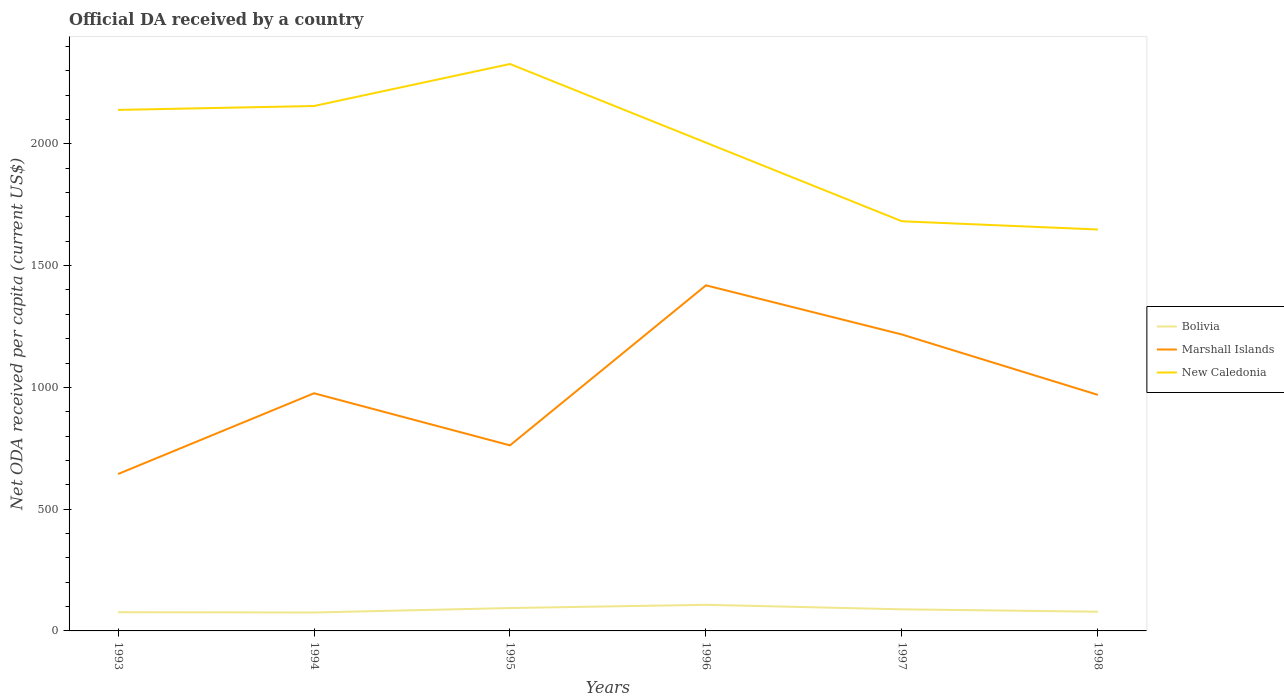How many different coloured lines are there?
Keep it short and to the point. 3. Is the number of lines equal to the number of legend labels?
Your answer should be very brief. Yes. Across all years, what is the maximum ODA received in in Bolivia?
Your answer should be compact. 75.66. What is the total ODA received in in Marshall Islands in the graph?
Your answer should be compact. -325.01. What is the difference between the highest and the second highest ODA received in in Marshall Islands?
Provide a succinct answer. 774.82. What is the difference between the highest and the lowest ODA received in in New Caledonia?
Keep it short and to the point. 4. What is the difference between two consecutive major ticks on the Y-axis?
Your answer should be compact. 500. Are the values on the major ticks of Y-axis written in scientific E-notation?
Ensure brevity in your answer.  No. Does the graph contain any zero values?
Your answer should be very brief. No. Does the graph contain grids?
Ensure brevity in your answer.  No. Where does the legend appear in the graph?
Provide a short and direct response. Center right. How are the legend labels stacked?
Offer a terse response. Vertical. What is the title of the graph?
Your answer should be compact. Official DA received by a country. Does "Mongolia" appear as one of the legend labels in the graph?
Offer a very short reply. No. What is the label or title of the X-axis?
Your answer should be very brief. Years. What is the label or title of the Y-axis?
Provide a short and direct response. Net ODA received per capita (current US$). What is the Net ODA received per capita (current US$) of Bolivia in 1993?
Your response must be concise. 76.85. What is the Net ODA received per capita (current US$) in Marshall Islands in 1993?
Your answer should be very brief. 644.33. What is the Net ODA received per capita (current US$) of New Caledonia in 1993?
Offer a terse response. 2139.5. What is the Net ODA received per capita (current US$) in Bolivia in 1994?
Your answer should be compact. 75.66. What is the Net ODA received per capita (current US$) of Marshall Islands in 1994?
Offer a very short reply. 975.94. What is the Net ODA received per capita (current US$) in New Caledonia in 1994?
Offer a terse response. 2155.51. What is the Net ODA received per capita (current US$) of Bolivia in 1995?
Your answer should be compact. 94.02. What is the Net ODA received per capita (current US$) of Marshall Islands in 1995?
Provide a succinct answer. 762.05. What is the Net ODA received per capita (current US$) of New Caledonia in 1995?
Your answer should be very brief. 2328.03. What is the Net ODA received per capita (current US$) of Bolivia in 1996?
Provide a short and direct response. 107.22. What is the Net ODA received per capita (current US$) of Marshall Islands in 1996?
Your answer should be very brief. 1419.15. What is the Net ODA received per capita (current US$) of New Caledonia in 1996?
Provide a short and direct response. 2005.12. What is the Net ODA received per capita (current US$) of Bolivia in 1997?
Your answer should be very brief. 88.65. What is the Net ODA received per capita (current US$) in Marshall Islands in 1997?
Offer a very short reply. 1217.29. What is the Net ODA received per capita (current US$) of New Caledonia in 1997?
Offer a terse response. 1682.17. What is the Net ODA received per capita (current US$) in Bolivia in 1998?
Ensure brevity in your answer.  78.87. What is the Net ODA received per capita (current US$) of Marshall Islands in 1998?
Offer a very short reply. 969.34. What is the Net ODA received per capita (current US$) of New Caledonia in 1998?
Offer a very short reply. 1648.44. Across all years, what is the maximum Net ODA received per capita (current US$) in Bolivia?
Make the answer very short. 107.22. Across all years, what is the maximum Net ODA received per capita (current US$) in Marshall Islands?
Your answer should be compact. 1419.15. Across all years, what is the maximum Net ODA received per capita (current US$) of New Caledonia?
Keep it short and to the point. 2328.03. Across all years, what is the minimum Net ODA received per capita (current US$) of Bolivia?
Keep it short and to the point. 75.66. Across all years, what is the minimum Net ODA received per capita (current US$) of Marshall Islands?
Keep it short and to the point. 644.33. Across all years, what is the minimum Net ODA received per capita (current US$) in New Caledonia?
Your answer should be very brief. 1648.44. What is the total Net ODA received per capita (current US$) in Bolivia in the graph?
Provide a short and direct response. 521.28. What is the total Net ODA received per capita (current US$) in Marshall Islands in the graph?
Keep it short and to the point. 5988.09. What is the total Net ODA received per capita (current US$) in New Caledonia in the graph?
Provide a short and direct response. 1.20e+04. What is the difference between the Net ODA received per capita (current US$) of Bolivia in 1993 and that in 1994?
Offer a terse response. 1.19. What is the difference between the Net ODA received per capita (current US$) of Marshall Islands in 1993 and that in 1994?
Give a very brief answer. -331.61. What is the difference between the Net ODA received per capita (current US$) of New Caledonia in 1993 and that in 1994?
Give a very brief answer. -16. What is the difference between the Net ODA received per capita (current US$) in Bolivia in 1993 and that in 1995?
Keep it short and to the point. -17.18. What is the difference between the Net ODA received per capita (current US$) of Marshall Islands in 1993 and that in 1995?
Ensure brevity in your answer.  -117.72. What is the difference between the Net ODA received per capita (current US$) of New Caledonia in 1993 and that in 1995?
Your response must be concise. -188.53. What is the difference between the Net ODA received per capita (current US$) of Bolivia in 1993 and that in 1996?
Provide a succinct answer. -30.38. What is the difference between the Net ODA received per capita (current US$) in Marshall Islands in 1993 and that in 1996?
Ensure brevity in your answer.  -774.82. What is the difference between the Net ODA received per capita (current US$) in New Caledonia in 1993 and that in 1996?
Keep it short and to the point. 134.38. What is the difference between the Net ODA received per capita (current US$) in Bolivia in 1993 and that in 1997?
Offer a terse response. -11.8. What is the difference between the Net ODA received per capita (current US$) of Marshall Islands in 1993 and that in 1997?
Your answer should be very brief. -572.96. What is the difference between the Net ODA received per capita (current US$) in New Caledonia in 1993 and that in 1997?
Give a very brief answer. 457.33. What is the difference between the Net ODA received per capita (current US$) in Bolivia in 1993 and that in 1998?
Your answer should be very brief. -2.02. What is the difference between the Net ODA received per capita (current US$) in Marshall Islands in 1993 and that in 1998?
Your answer should be compact. -325.01. What is the difference between the Net ODA received per capita (current US$) of New Caledonia in 1993 and that in 1998?
Give a very brief answer. 491.06. What is the difference between the Net ODA received per capita (current US$) in Bolivia in 1994 and that in 1995?
Provide a short and direct response. -18.37. What is the difference between the Net ODA received per capita (current US$) of Marshall Islands in 1994 and that in 1995?
Provide a succinct answer. 213.88. What is the difference between the Net ODA received per capita (current US$) of New Caledonia in 1994 and that in 1995?
Make the answer very short. -172.52. What is the difference between the Net ODA received per capita (current US$) in Bolivia in 1994 and that in 1996?
Give a very brief answer. -31.57. What is the difference between the Net ODA received per capita (current US$) in Marshall Islands in 1994 and that in 1996?
Give a very brief answer. -443.21. What is the difference between the Net ODA received per capita (current US$) of New Caledonia in 1994 and that in 1996?
Provide a succinct answer. 150.39. What is the difference between the Net ODA received per capita (current US$) in Bolivia in 1994 and that in 1997?
Your answer should be compact. -12.99. What is the difference between the Net ODA received per capita (current US$) of Marshall Islands in 1994 and that in 1997?
Your response must be concise. -241.35. What is the difference between the Net ODA received per capita (current US$) of New Caledonia in 1994 and that in 1997?
Give a very brief answer. 473.33. What is the difference between the Net ODA received per capita (current US$) of Bolivia in 1994 and that in 1998?
Give a very brief answer. -3.22. What is the difference between the Net ODA received per capita (current US$) of Marshall Islands in 1994 and that in 1998?
Your response must be concise. 6.6. What is the difference between the Net ODA received per capita (current US$) of New Caledonia in 1994 and that in 1998?
Provide a short and direct response. 507.07. What is the difference between the Net ODA received per capita (current US$) of Bolivia in 1995 and that in 1996?
Offer a terse response. -13.2. What is the difference between the Net ODA received per capita (current US$) in Marshall Islands in 1995 and that in 1996?
Offer a terse response. -657.09. What is the difference between the Net ODA received per capita (current US$) in New Caledonia in 1995 and that in 1996?
Offer a very short reply. 322.91. What is the difference between the Net ODA received per capita (current US$) in Bolivia in 1995 and that in 1997?
Provide a succinct answer. 5.38. What is the difference between the Net ODA received per capita (current US$) in Marshall Islands in 1995 and that in 1997?
Keep it short and to the point. -455.23. What is the difference between the Net ODA received per capita (current US$) of New Caledonia in 1995 and that in 1997?
Ensure brevity in your answer.  645.86. What is the difference between the Net ODA received per capita (current US$) of Bolivia in 1995 and that in 1998?
Provide a short and direct response. 15.15. What is the difference between the Net ODA received per capita (current US$) of Marshall Islands in 1995 and that in 1998?
Provide a short and direct response. -207.28. What is the difference between the Net ODA received per capita (current US$) in New Caledonia in 1995 and that in 1998?
Your answer should be very brief. 679.59. What is the difference between the Net ODA received per capita (current US$) of Bolivia in 1996 and that in 1997?
Your response must be concise. 18.57. What is the difference between the Net ODA received per capita (current US$) in Marshall Islands in 1996 and that in 1997?
Provide a short and direct response. 201.86. What is the difference between the Net ODA received per capita (current US$) in New Caledonia in 1996 and that in 1997?
Offer a terse response. 322.95. What is the difference between the Net ODA received per capita (current US$) in Bolivia in 1996 and that in 1998?
Your answer should be very brief. 28.35. What is the difference between the Net ODA received per capita (current US$) in Marshall Islands in 1996 and that in 1998?
Ensure brevity in your answer.  449.81. What is the difference between the Net ODA received per capita (current US$) of New Caledonia in 1996 and that in 1998?
Provide a succinct answer. 356.68. What is the difference between the Net ODA received per capita (current US$) of Bolivia in 1997 and that in 1998?
Keep it short and to the point. 9.78. What is the difference between the Net ODA received per capita (current US$) in Marshall Islands in 1997 and that in 1998?
Offer a very short reply. 247.95. What is the difference between the Net ODA received per capita (current US$) of New Caledonia in 1997 and that in 1998?
Provide a short and direct response. 33.73. What is the difference between the Net ODA received per capita (current US$) of Bolivia in 1993 and the Net ODA received per capita (current US$) of Marshall Islands in 1994?
Provide a short and direct response. -899.09. What is the difference between the Net ODA received per capita (current US$) in Bolivia in 1993 and the Net ODA received per capita (current US$) in New Caledonia in 1994?
Give a very brief answer. -2078.66. What is the difference between the Net ODA received per capita (current US$) of Marshall Islands in 1993 and the Net ODA received per capita (current US$) of New Caledonia in 1994?
Provide a succinct answer. -1511.18. What is the difference between the Net ODA received per capita (current US$) in Bolivia in 1993 and the Net ODA received per capita (current US$) in Marshall Islands in 1995?
Offer a terse response. -685.2. What is the difference between the Net ODA received per capita (current US$) of Bolivia in 1993 and the Net ODA received per capita (current US$) of New Caledonia in 1995?
Keep it short and to the point. -2251.18. What is the difference between the Net ODA received per capita (current US$) in Marshall Islands in 1993 and the Net ODA received per capita (current US$) in New Caledonia in 1995?
Provide a short and direct response. -1683.7. What is the difference between the Net ODA received per capita (current US$) of Bolivia in 1993 and the Net ODA received per capita (current US$) of Marshall Islands in 1996?
Your answer should be very brief. -1342.3. What is the difference between the Net ODA received per capita (current US$) in Bolivia in 1993 and the Net ODA received per capita (current US$) in New Caledonia in 1996?
Your answer should be very brief. -1928.27. What is the difference between the Net ODA received per capita (current US$) of Marshall Islands in 1993 and the Net ODA received per capita (current US$) of New Caledonia in 1996?
Provide a short and direct response. -1360.79. What is the difference between the Net ODA received per capita (current US$) of Bolivia in 1993 and the Net ODA received per capita (current US$) of Marshall Islands in 1997?
Offer a terse response. -1140.44. What is the difference between the Net ODA received per capita (current US$) of Bolivia in 1993 and the Net ODA received per capita (current US$) of New Caledonia in 1997?
Offer a very short reply. -1605.32. What is the difference between the Net ODA received per capita (current US$) in Marshall Islands in 1993 and the Net ODA received per capita (current US$) in New Caledonia in 1997?
Ensure brevity in your answer.  -1037.84. What is the difference between the Net ODA received per capita (current US$) in Bolivia in 1993 and the Net ODA received per capita (current US$) in Marshall Islands in 1998?
Provide a succinct answer. -892.49. What is the difference between the Net ODA received per capita (current US$) of Bolivia in 1993 and the Net ODA received per capita (current US$) of New Caledonia in 1998?
Keep it short and to the point. -1571.59. What is the difference between the Net ODA received per capita (current US$) in Marshall Islands in 1993 and the Net ODA received per capita (current US$) in New Caledonia in 1998?
Provide a short and direct response. -1004.11. What is the difference between the Net ODA received per capita (current US$) of Bolivia in 1994 and the Net ODA received per capita (current US$) of Marshall Islands in 1995?
Provide a succinct answer. -686.4. What is the difference between the Net ODA received per capita (current US$) in Bolivia in 1994 and the Net ODA received per capita (current US$) in New Caledonia in 1995?
Make the answer very short. -2252.38. What is the difference between the Net ODA received per capita (current US$) of Marshall Islands in 1994 and the Net ODA received per capita (current US$) of New Caledonia in 1995?
Give a very brief answer. -1352.1. What is the difference between the Net ODA received per capita (current US$) of Bolivia in 1994 and the Net ODA received per capita (current US$) of Marshall Islands in 1996?
Ensure brevity in your answer.  -1343.49. What is the difference between the Net ODA received per capita (current US$) in Bolivia in 1994 and the Net ODA received per capita (current US$) in New Caledonia in 1996?
Offer a very short reply. -1929.47. What is the difference between the Net ODA received per capita (current US$) in Marshall Islands in 1994 and the Net ODA received per capita (current US$) in New Caledonia in 1996?
Make the answer very short. -1029.18. What is the difference between the Net ODA received per capita (current US$) in Bolivia in 1994 and the Net ODA received per capita (current US$) in Marshall Islands in 1997?
Give a very brief answer. -1141.63. What is the difference between the Net ODA received per capita (current US$) in Bolivia in 1994 and the Net ODA received per capita (current US$) in New Caledonia in 1997?
Your response must be concise. -1606.52. What is the difference between the Net ODA received per capita (current US$) of Marshall Islands in 1994 and the Net ODA received per capita (current US$) of New Caledonia in 1997?
Keep it short and to the point. -706.24. What is the difference between the Net ODA received per capita (current US$) in Bolivia in 1994 and the Net ODA received per capita (current US$) in Marshall Islands in 1998?
Offer a terse response. -893.68. What is the difference between the Net ODA received per capita (current US$) of Bolivia in 1994 and the Net ODA received per capita (current US$) of New Caledonia in 1998?
Your answer should be compact. -1572.78. What is the difference between the Net ODA received per capita (current US$) in Marshall Islands in 1994 and the Net ODA received per capita (current US$) in New Caledonia in 1998?
Give a very brief answer. -672.5. What is the difference between the Net ODA received per capita (current US$) of Bolivia in 1995 and the Net ODA received per capita (current US$) of Marshall Islands in 1996?
Your answer should be very brief. -1325.12. What is the difference between the Net ODA received per capita (current US$) in Bolivia in 1995 and the Net ODA received per capita (current US$) in New Caledonia in 1996?
Your answer should be very brief. -1911.1. What is the difference between the Net ODA received per capita (current US$) of Marshall Islands in 1995 and the Net ODA received per capita (current US$) of New Caledonia in 1996?
Your response must be concise. -1243.07. What is the difference between the Net ODA received per capita (current US$) of Bolivia in 1995 and the Net ODA received per capita (current US$) of Marshall Islands in 1997?
Offer a very short reply. -1123.26. What is the difference between the Net ODA received per capita (current US$) in Bolivia in 1995 and the Net ODA received per capita (current US$) in New Caledonia in 1997?
Your answer should be very brief. -1588.15. What is the difference between the Net ODA received per capita (current US$) of Marshall Islands in 1995 and the Net ODA received per capita (current US$) of New Caledonia in 1997?
Ensure brevity in your answer.  -920.12. What is the difference between the Net ODA received per capita (current US$) in Bolivia in 1995 and the Net ODA received per capita (current US$) in Marshall Islands in 1998?
Make the answer very short. -875.31. What is the difference between the Net ODA received per capita (current US$) in Bolivia in 1995 and the Net ODA received per capita (current US$) in New Caledonia in 1998?
Your answer should be very brief. -1554.41. What is the difference between the Net ODA received per capita (current US$) in Marshall Islands in 1995 and the Net ODA received per capita (current US$) in New Caledonia in 1998?
Provide a succinct answer. -886.39. What is the difference between the Net ODA received per capita (current US$) of Bolivia in 1996 and the Net ODA received per capita (current US$) of Marshall Islands in 1997?
Make the answer very short. -1110.06. What is the difference between the Net ODA received per capita (current US$) in Bolivia in 1996 and the Net ODA received per capita (current US$) in New Caledonia in 1997?
Offer a terse response. -1574.95. What is the difference between the Net ODA received per capita (current US$) in Marshall Islands in 1996 and the Net ODA received per capita (current US$) in New Caledonia in 1997?
Keep it short and to the point. -263.02. What is the difference between the Net ODA received per capita (current US$) in Bolivia in 1996 and the Net ODA received per capita (current US$) in Marshall Islands in 1998?
Ensure brevity in your answer.  -862.11. What is the difference between the Net ODA received per capita (current US$) of Bolivia in 1996 and the Net ODA received per capita (current US$) of New Caledonia in 1998?
Offer a terse response. -1541.21. What is the difference between the Net ODA received per capita (current US$) of Marshall Islands in 1996 and the Net ODA received per capita (current US$) of New Caledonia in 1998?
Your response must be concise. -229.29. What is the difference between the Net ODA received per capita (current US$) in Bolivia in 1997 and the Net ODA received per capita (current US$) in Marshall Islands in 1998?
Give a very brief answer. -880.69. What is the difference between the Net ODA received per capita (current US$) in Bolivia in 1997 and the Net ODA received per capita (current US$) in New Caledonia in 1998?
Your response must be concise. -1559.79. What is the difference between the Net ODA received per capita (current US$) in Marshall Islands in 1997 and the Net ODA received per capita (current US$) in New Caledonia in 1998?
Provide a succinct answer. -431.15. What is the average Net ODA received per capita (current US$) in Bolivia per year?
Give a very brief answer. 86.88. What is the average Net ODA received per capita (current US$) of Marshall Islands per year?
Your answer should be compact. 998.02. What is the average Net ODA received per capita (current US$) in New Caledonia per year?
Your response must be concise. 1993.13. In the year 1993, what is the difference between the Net ODA received per capita (current US$) of Bolivia and Net ODA received per capita (current US$) of Marshall Islands?
Offer a terse response. -567.48. In the year 1993, what is the difference between the Net ODA received per capita (current US$) of Bolivia and Net ODA received per capita (current US$) of New Caledonia?
Your answer should be very brief. -2062.65. In the year 1993, what is the difference between the Net ODA received per capita (current US$) of Marshall Islands and Net ODA received per capita (current US$) of New Caledonia?
Give a very brief answer. -1495.17. In the year 1994, what is the difference between the Net ODA received per capita (current US$) of Bolivia and Net ODA received per capita (current US$) of Marshall Islands?
Your response must be concise. -900.28. In the year 1994, what is the difference between the Net ODA received per capita (current US$) of Bolivia and Net ODA received per capita (current US$) of New Caledonia?
Offer a very short reply. -2079.85. In the year 1994, what is the difference between the Net ODA received per capita (current US$) in Marshall Islands and Net ODA received per capita (current US$) in New Caledonia?
Ensure brevity in your answer.  -1179.57. In the year 1995, what is the difference between the Net ODA received per capita (current US$) of Bolivia and Net ODA received per capita (current US$) of Marshall Islands?
Keep it short and to the point. -668.03. In the year 1995, what is the difference between the Net ODA received per capita (current US$) in Bolivia and Net ODA received per capita (current US$) in New Caledonia?
Give a very brief answer. -2234.01. In the year 1995, what is the difference between the Net ODA received per capita (current US$) in Marshall Islands and Net ODA received per capita (current US$) in New Caledonia?
Keep it short and to the point. -1565.98. In the year 1996, what is the difference between the Net ODA received per capita (current US$) of Bolivia and Net ODA received per capita (current US$) of Marshall Islands?
Your answer should be very brief. -1311.92. In the year 1996, what is the difference between the Net ODA received per capita (current US$) in Bolivia and Net ODA received per capita (current US$) in New Caledonia?
Keep it short and to the point. -1897.9. In the year 1996, what is the difference between the Net ODA received per capita (current US$) of Marshall Islands and Net ODA received per capita (current US$) of New Caledonia?
Ensure brevity in your answer.  -585.97. In the year 1997, what is the difference between the Net ODA received per capita (current US$) in Bolivia and Net ODA received per capita (current US$) in Marshall Islands?
Make the answer very short. -1128.64. In the year 1997, what is the difference between the Net ODA received per capita (current US$) in Bolivia and Net ODA received per capita (current US$) in New Caledonia?
Your answer should be compact. -1593.52. In the year 1997, what is the difference between the Net ODA received per capita (current US$) in Marshall Islands and Net ODA received per capita (current US$) in New Caledonia?
Give a very brief answer. -464.89. In the year 1998, what is the difference between the Net ODA received per capita (current US$) in Bolivia and Net ODA received per capita (current US$) in Marshall Islands?
Offer a very short reply. -890.47. In the year 1998, what is the difference between the Net ODA received per capita (current US$) of Bolivia and Net ODA received per capita (current US$) of New Caledonia?
Provide a short and direct response. -1569.57. In the year 1998, what is the difference between the Net ODA received per capita (current US$) in Marshall Islands and Net ODA received per capita (current US$) in New Caledonia?
Your response must be concise. -679.1. What is the ratio of the Net ODA received per capita (current US$) in Bolivia in 1993 to that in 1994?
Give a very brief answer. 1.02. What is the ratio of the Net ODA received per capita (current US$) in Marshall Islands in 1993 to that in 1994?
Provide a succinct answer. 0.66. What is the ratio of the Net ODA received per capita (current US$) in New Caledonia in 1993 to that in 1994?
Provide a short and direct response. 0.99. What is the ratio of the Net ODA received per capita (current US$) of Bolivia in 1993 to that in 1995?
Ensure brevity in your answer.  0.82. What is the ratio of the Net ODA received per capita (current US$) in Marshall Islands in 1993 to that in 1995?
Your answer should be compact. 0.85. What is the ratio of the Net ODA received per capita (current US$) of New Caledonia in 1993 to that in 1995?
Ensure brevity in your answer.  0.92. What is the ratio of the Net ODA received per capita (current US$) in Bolivia in 1993 to that in 1996?
Provide a short and direct response. 0.72. What is the ratio of the Net ODA received per capita (current US$) of Marshall Islands in 1993 to that in 1996?
Your answer should be very brief. 0.45. What is the ratio of the Net ODA received per capita (current US$) in New Caledonia in 1993 to that in 1996?
Your answer should be compact. 1.07. What is the ratio of the Net ODA received per capita (current US$) in Bolivia in 1993 to that in 1997?
Ensure brevity in your answer.  0.87. What is the ratio of the Net ODA received per capita (current US$) in Marshall Islands in 1993 to that in 1997?
Provide a succinct answer. 0.53. What is the ratio of the Net ODA received per capita (current US$) of New Caledonia in 1993 to that in 1997?
Your answer should be compact. 1.27. What is the ratio of the Net ODA received per capita (current US$) in Bolivia in 1993 to that in 1998?
Make the answer very short. 0.97. What is the ratio of the Net ODA received per capita (current US$) of Marshall Islands in 1993 to that in 1998?
Make the answer very short. 0.66. What is the ratio of the Net ODA received per capita (current US$) of New Caledonia in 1993 to that in 1998?
Offer a very short reply. 1.3. What is the ratio of the Net ODA received per capita (current US$) of Bolivia in 1994 to that in 1995?
Keep it short and to the point. 0.8. What is the ratio of the Net ODA received per capita (current US$) of Marshall Islands in 1994 to that in 1995?
Your answer should be very brief. 1.28. What is the ratio of the Net ODA received per capita (current US$) in New Caledonia in 1994 to that in 1995?
Provide a succinct answer. 0.93. What is the ratio of the Net ODA received per capita (current US$) in Bolivia in 1994 to that in 1996?
Give a very brief answer. 0.71. What is the ratio of the Net ODA received per capita (current US$) of Marshall Islands in 1994 to that in 1996?
Provide a short and direct response. 0.69. What is the ratio of the Net ODA received per capita (current US$) in New Caledonia in 1994 to that in 1996?
Your response must be concise. 1.07. What is the ratio of the Net ODA received per capita (current US$) of Bolivia in 1994 to that in 1997?
Your answer should be compact. 0.85. What is the ratio of the Net ODA received per capita (current US$) of Marshall Islands in 1994 to that in 1997?
Give a very brief answer. 0.8. What is the ratio of the Net ODA received per capita (current US$) in New Caledonia in 1994 to that in 1997?
Give a very brief answer. 1.28. What is the ratio of the Net ODA received per capita (current US$) of Bolivia in 1994 to that in 1998?
Give a very brief answer. 0.96. What is the ratio of the Net ODA received per capita (current US$) of Marshall Islands in 1994 to that in 1998?
Your answer should be very brief. 1.01. What is the ratio of the Net ODA received per capita (current US$) of New Caledonia in 1994 to that in 1998?
Offer a very short reply. 1.31. What is the ratio of the Net ODA received per capita (current US$) in Bolivia in 1995 to that in 1996?
Keep it short and to the point. 0.88. What is the ratio of the Net ODA received per capita (current US$) in Marshall Islands in 1995 to that in 1996?
Provide a short and direct response. 0.54. What is the ratio of the Net ODA received per capita (current US$) of New Caledonia in 1995 to that in 1996?
Ensure brevity in your answer.  1.16. What is the ratio of the Net ODA received per capita (current US$) of Bolivia in 1995 to that in 1997?
Offer a very short reply. 1.06. What is the ratio of the Net ODA received per capita (current US$) in Marshall Islands in 1995 to that in 1997?
Your answer should be compact. 0.63. What is the ratio of the Net ODA received per capita (current US$) in New Caledonia in 1995 to that in 1997?
Give a very brief answer. 1.38. What is the ratio of the Net ODA received per capita (current US$) in Bolivia in 1995 to that in 1998?
Provide a short and direct response. 1.19. What is the ratio of the Net ODA received per capita (current US$) in Marshall Islands in 1995 to that in 1998?
Offer a terse response. 0.79. What is the ratio of the Net ODA received per capita (current US$) of New Caledonia in 1995 to that in 1998?
Your answer should be very brief. 1.41. What is the ratio of the Net ODA received per capita (current US$) in Bolivia in 1996 to that in 1997?
Provide a succinct answer. 1.21. What is the ratio of the Net ODA received per capita (current US$) in Marshall Islands in 1996 to that in 1997?
Your answer should be compact. 1.17. What is the ratio of the Net ODA received per capita (current US$) in New Caledonia in 1996 to that in 1997?
Provide a succinct answer. 1.19. What is the ratio of the Net ODA received per capita (current US$) in Bolivia in 1996 to that in 1998?
Offer a very short reply. 1.36. What is the ratio of the Net ODA received per capita (current US$) of Marshall Islands in 1996 to that in 1998?
Make the answer very short. 1.46. What is the ratio of the Net ODA received per capita (current US$) in New Caledonia in 1996 to that in 1998?
Provide a succinct answer. 1.22. What is the ratio of the Net ODA received per capita (current US$) of Bolivia in 1997 to that in 1998?
Give a very brief answer. 1.12. What is the ratio of the Net ODA received per capita (current US$) of Marshall Islands in 1997 to that in 1998?
Provide a short and direct response. 1.26. What is the ratio of the Net ODA received per capita (current US$) in New Caledonia in 1997 to that in 1998?
Provide a succinct answer. 1.02. What is the difference between the highest and the second highest Net ODA received per capita (current US$) in Bolivia?
Your answer should be compact. 13.2. What is the difference between the highest and the second highest Net ODA received per capita (current US$) of Marshall Islands?
Offer a very short reply. 201.86. What is the difference between the highest and the second highest Net ODA received per capita (current US$) of New Caledonia?
Keep it short and to the point. 172.52. What is the difference between the highest and the lowest Net ODA received per capita (current US$) in Bolivia?
Keep it short and to the point. 31.57. What is the difference between the highest and the lowest Net ODA received per capita (current US$) of Marshall Islands?
Ensure brevity in your answer.  774.82. What is the difference between the highest and the lowest Net ODA received per capita (current US$) in New Caledonia?
Offer a very short reply. 679.59. 